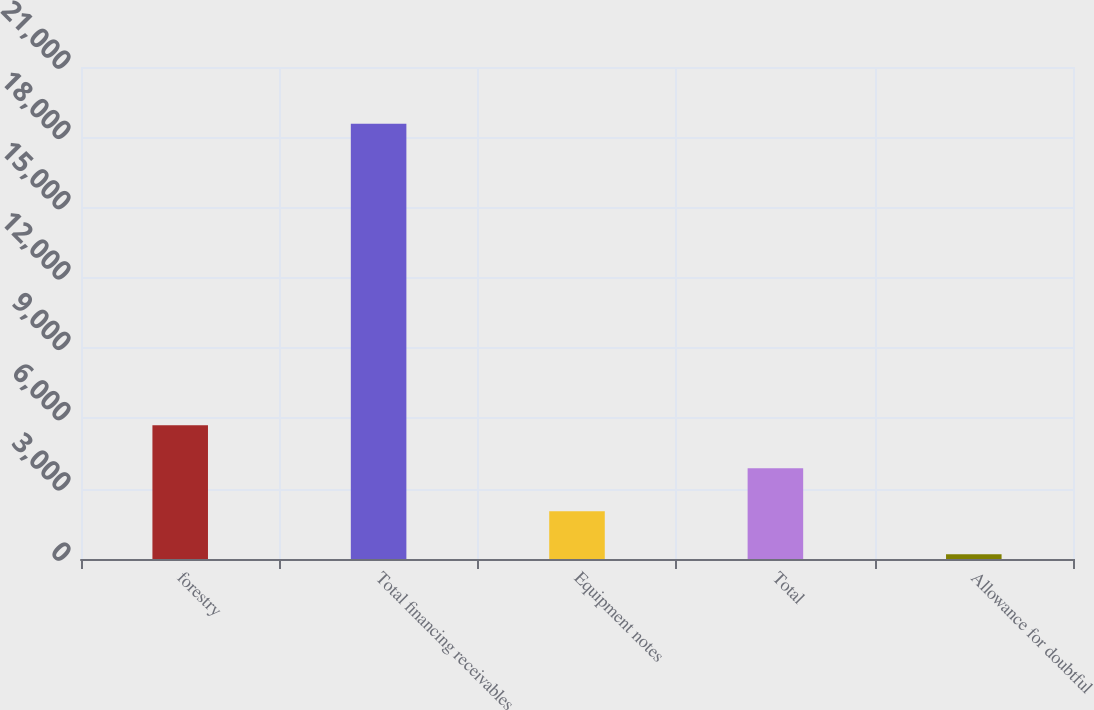Convert chart to OTSL. <chart><loc_0><loc_0><loc_500><loc_500><bar_chart><fcel>forestry<fcel>Total financing receivables<fcel>Equipment notes<fcel>Total<fcel>Allowance for doubtful<nl><fcel>5713.5<fcel>18583<fcel>2036.5<fcel>3875<fcel>198<nl></chart> 